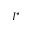Convert formula to latex. <formula><loc_0><loc_0><loc_500><loc_500>I ^ { ^ { * } }</formula> 